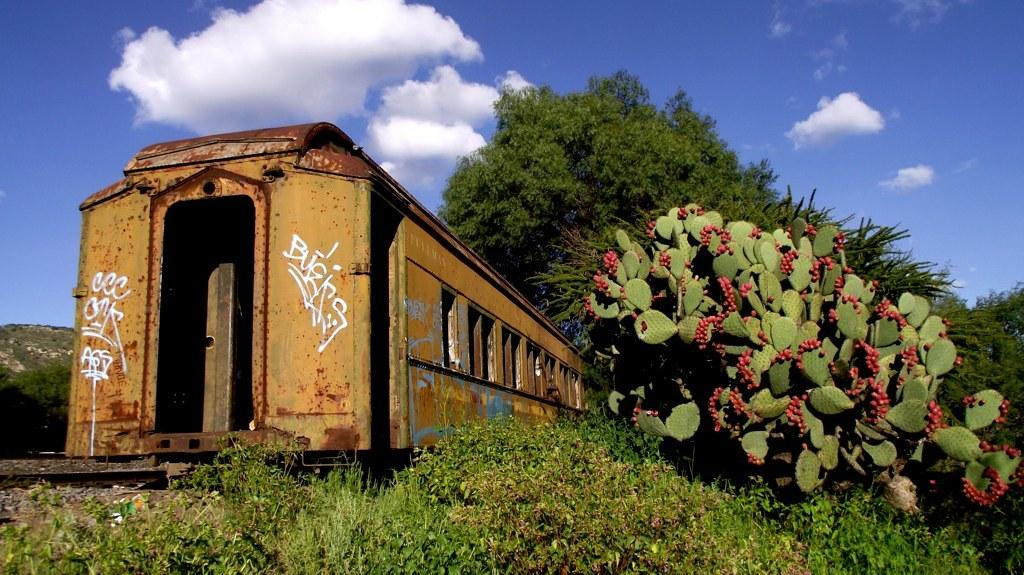What type of vehicle is shown in the image? There is a train compartment in the image. What other objects or elements can be seen in the image? There are plants and trees visible in the image. What can be seen in the background of the image? The sky is visible in the background of the image. What type of vessel is being used for learning in the image? There is no vessel or learning activity depicted in the image; it features a train compartment, plants, trees, and the sky. 